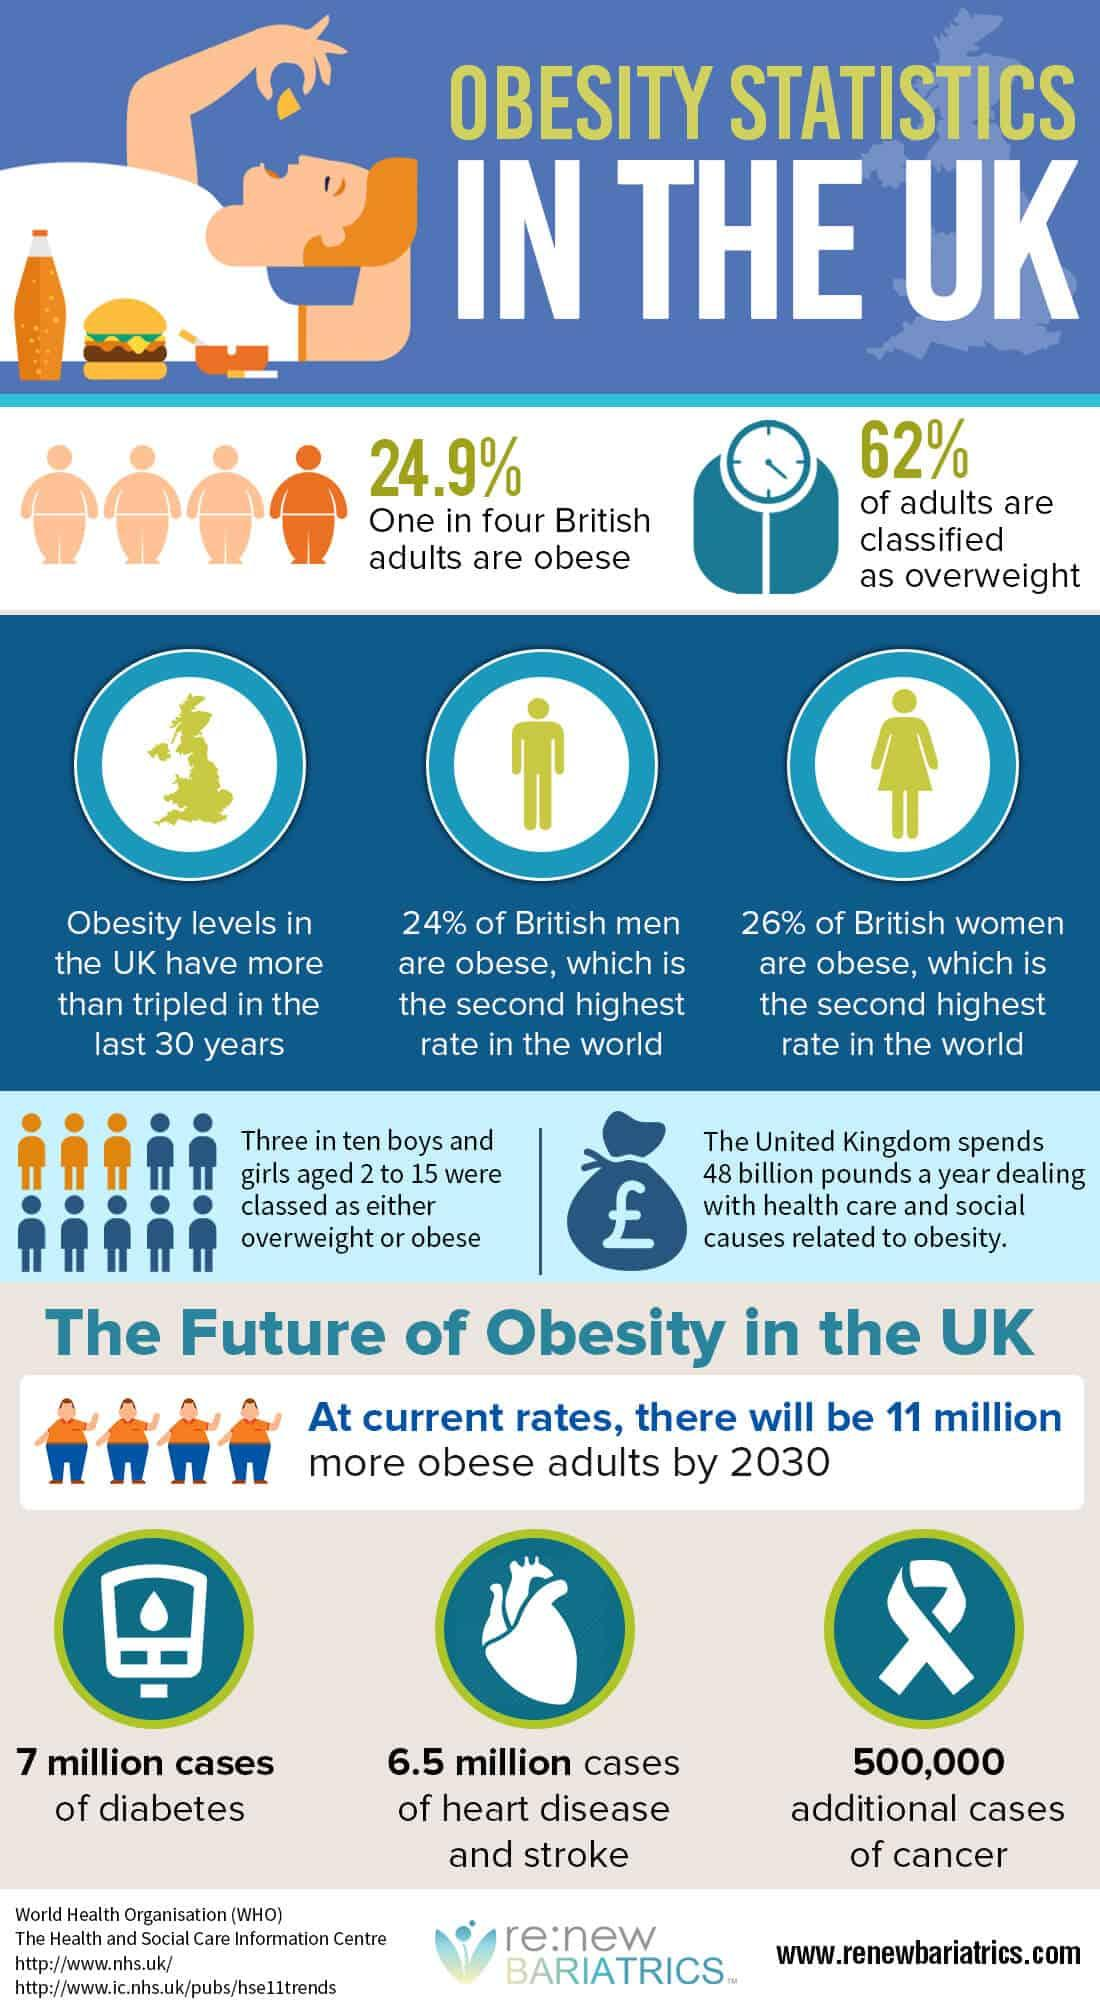Draw attention to some important aspects in this diagram. In 2018, it was reported that 30% of boys and girls aged 2 to 15 were classified as either overweight or obese. Approximately 62% of adults are considered to be overweight. 